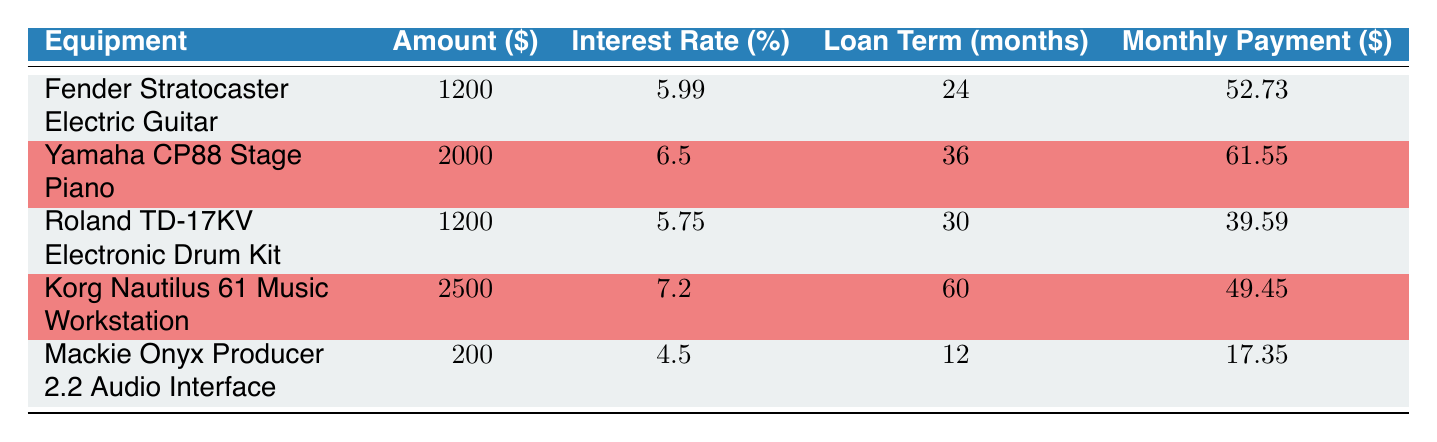What is the monthly payment for the Yamaha CP88 Stage Piano? The table indicates that the monthly payment for the Yamaha CP88 Stage Piano is listed directly under the "Monthly Payment" column, corresponding to the row for this equipment. The value specified is 61.55.
Answer: 61.55 Which equipment has the lowest interest rate? By comparing the interest rates in the table, the Mackie Onyx Producer 2.2 Audio Interface has the lowest interest rate of 4.5% among the listed financing options.
Answer: Mackie Onyx Producer 2.2 Audio Interface How much total will be paid for the Korg Nautilus 61 Music Workstation over the loan term? To find the total payment over the loan term for the Korg Nautilus 61 Music Workstation, multiply the monthly payment (49.45) by the loan term (60 months): 49.45 * 60 = 2967.
Answer: 2967 Is the monthly payment for the Roland TD-17KV Electronic Drum Kit lower than the average monthly payment of all equipment? First, we need to find the average monthly payment. The monthly payments for each item are 52.73, 61.55, 39.59, 49.45, and 17.35. The total is 220.67, and the average is 220.67 / 5 = 44.134. Since 39.59 is lower than 44.134, the answer is yes.
Answer: Yes What is the difference in monthly payments between the Fender Stratocaster Electric Guitar and the Yamaha CP88 Stage Piano? The monthly payments are 52.73 for the Fender Stratocaster and 61.55 for the Yamaha CP88 Stage Piano. The difference is calculated by subtracting 52.73 from 61.55: 61.55 - 52.73 = 8.82.
Answer: 8.82 How much more is the loan amount for the Korg Nautilus 61 Music Workstation compared to the Mackie Onyx? The loan amounts for the Korg Nautilus 61 Music Workstation and the Mackie Onyx Producer 2.2 Audio Interface are 2500 and 200 respectively. The difference is 2500 - 200 = 2300.
Answer: 2300 Does any of the equipment have a loan term of less than 24 months? According to the table, the Mackie Onyx Producer 2.2 Audio Interface has a loan term of 12 months, which is indeed less than 24 months.
Answer: Yes What is the average interest rate of all the financing options? To find the average interest rate, add all the interest rates: 5.99 + 6.5 + 5.75 + 7.2 + 4.5 = 30.94. Then, divide this sum by the number of options (5): 30.94 / 5 = 6.188.
Answer: 6.188 What is the equipment with the highest loan amount? By examining the "Amount" column, the Korg Nautilus 61 Music Workstation has the highest loan amount listed at 2500.
Answer: Korg Nautilus 61 Music Workstation 